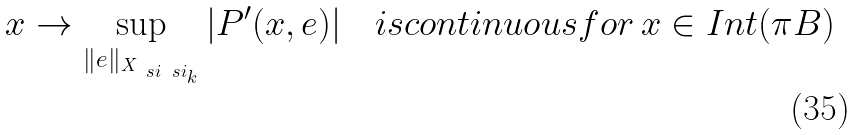<formula> <loc_0><loc_0><loc_500><loc_500>x \rightarrow \sup _ { \| e \| _ { X _ { \ s i \ s i _ { k } } } } | P ^ { \prime } ( x , e ) | \quad i s c o n t i n u o u s f o r \, x \in I n t ( \pi B )</formula> 